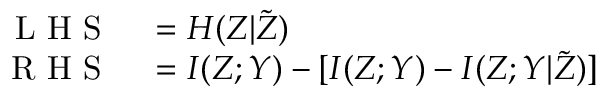<formula> <loc_0><loc_0><loc_500><loc_500>\begin{array} { r l } { L H S } & = H ( Z | \tilde { Z } ) } \\ { R H S } & = I ( Z ; Y ) - [ I ( Z ; Y ) - I ( Z ; Y | \tilde { Z } ) ] } \end{array}</formula> 